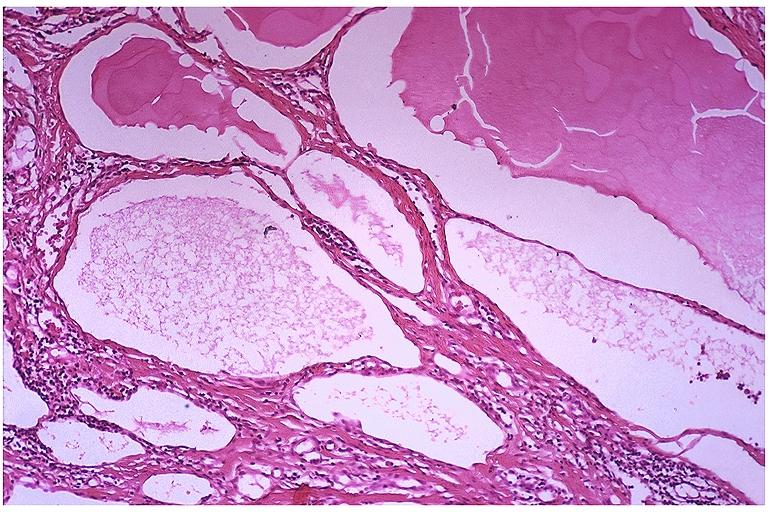what is present?
Answer the question using a single word or phrase. Oral 